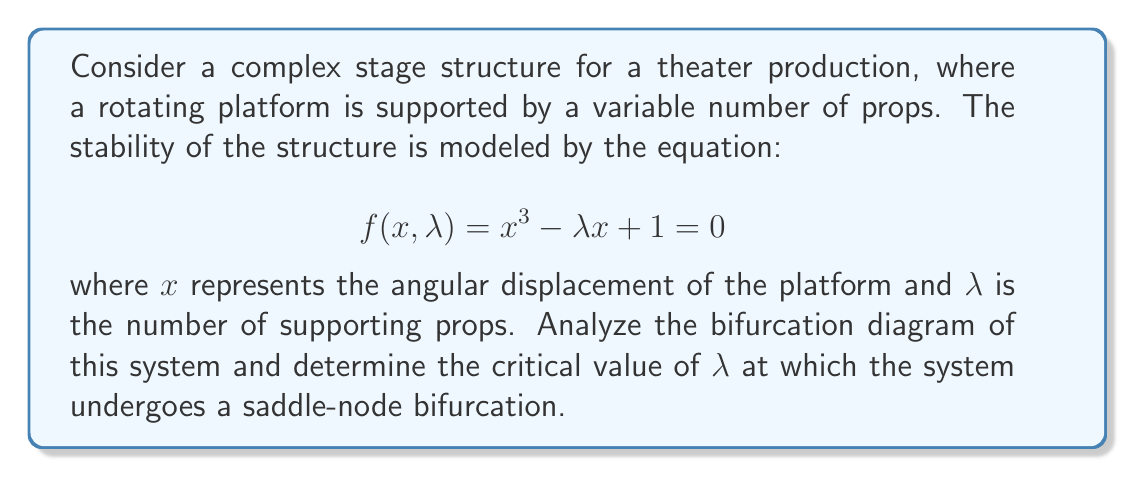Could you help me with this problem? To analyze the stability and find the saddle-node bifurcation point, we follow these steps:

1) First, we need to find the critical points of the system. These occur when both $f(x,\lambda) = 0$ and $\frac{\partial f}{\partial x} = 0$. 

2) Taking the partial derivative with respect to x:

   $$\frac{\partial f}{\partial x} = 3x^2 - \lambda$$

3) Setting this equal to zero:

   $$3x^2 - \lambda = 0$$
   $$x^2 = \frac{\lambda}{3}$$
   $$x = \pm \sqrt{\frac{\lambda}{3}}$$

4) Now, we substitute this back into the original equation:

   $$(\pm \sqrt{\frac{\lambda}{3}})^3 - \lambda(\pm \sqrt{\frac{\lambda}{3}}) + 1 = 0$$

5) Simplifying:

   $$\pm \frac{\lambda\sqrt{\lambda}}{3\sqrt{3}} - \lambda(\pm \sqrt{\frac{\lambda}{3}}) + 1 = 0$$
   $$\pm \frac{\lambda\sqrt{\lambda}}{3\sqrt{3}} \mp \lambda\sqrt{\frac{\lambda}{3}} + 1 = 0$$
   $$\pm \frac{\lambda\sqrt{\lambda}}{3\sqrt{3}} \mp \frac{\lambda\sqrt{3\lambda}}{3\sqrt{3}} + 1 = 0$$

6) The $\pm$ terms cancel out, leaving:

   $$-\frac{2\lambda\sqrt{\lambda}}{3\sqrt{3}} + 1 = 0$$

7) Solving for $\lambda$:

   $$\frac{2\lambda\sqrt{\lambda}}{3\sqrt{3}} = 1$$
   $$2\lambda\sqrt{\lambda} = 3\sqrt{3}$$
   $$4\lambda^3 = 27$$
   $$\lambda^3 = \frac{27}{4}$$
   $$\lambda = \sqrt[3]{\frac{27}{4}} = 3$$

Therefore, the saddle-node bifurcation occurs at $\lambda = 3$.
Answer: $\lambda = 3$ 